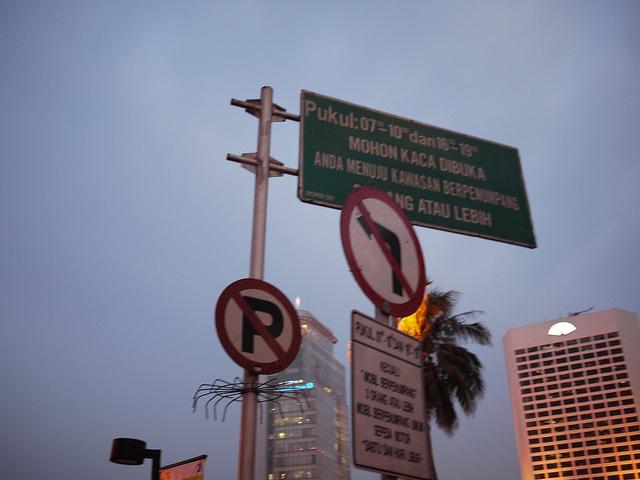How many arrow signs?
Give a very brief answer. 1. Is it daytime?
Concise answer only. No. What color is the largest sign?
Quick response, please. Green. Is parking allowed?
Give a very brief answer. No. 